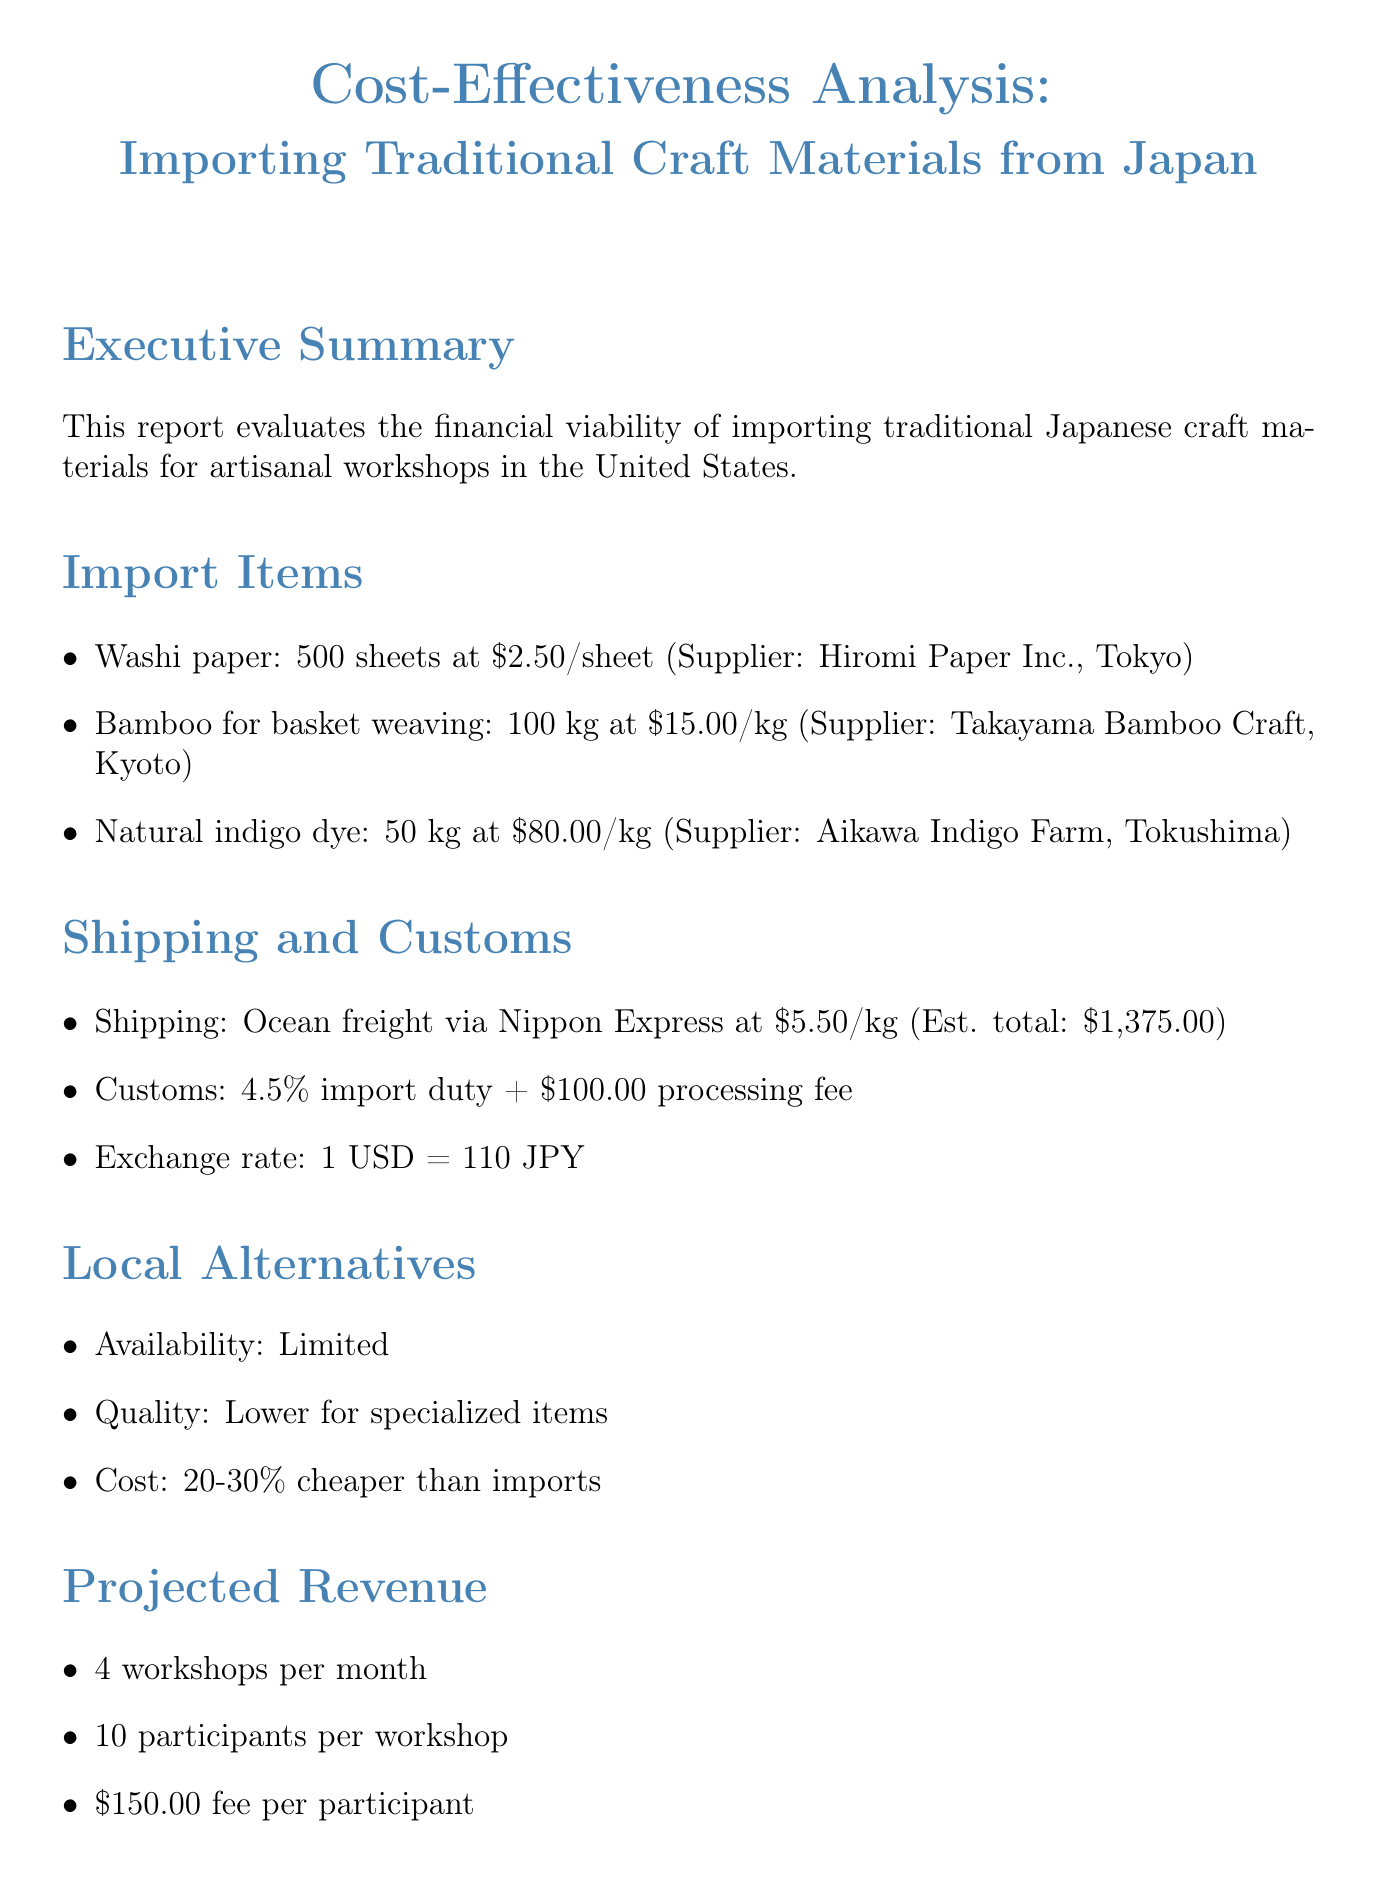What is the unit cost of Washi paper? The unit cost of Washi paper is specified in the import items section of the document.
Answer: $2.50 Who is the supplier of Bamboo for basket weaving? The supplier's name is found in the import items section next to Bamboo for basket weaving.
Answer: Takayama Bamboo Craft, Kyoto What is the estimated total shipping cost? The estimated total shipping cost is mentioned in the shipping costs section of the document.
Answer: $1,375.00 What is the import duty percentage? The import duty percentage is indicated in the customs fees section.
Answer: 4.5% How many workshops are projected per month? The number of workshops per month is detailed in the projected revenue section.
Answer: 4 What is the fee per participant in the workshops? The fee per participant is clearly stated in the projected revenue section of the document.
Answer: $150.00 What does the report conclude about cost-effectiveness? The conclusion regarding cost-effectiveness is provided in the conclusion section of the document.
Answer: Moderate What is the recommendation given in the report? The recommendation is found in the conclusion section.
Answer: Proceed with import plan, focusing on unique, high-quality materials unavailable locally 